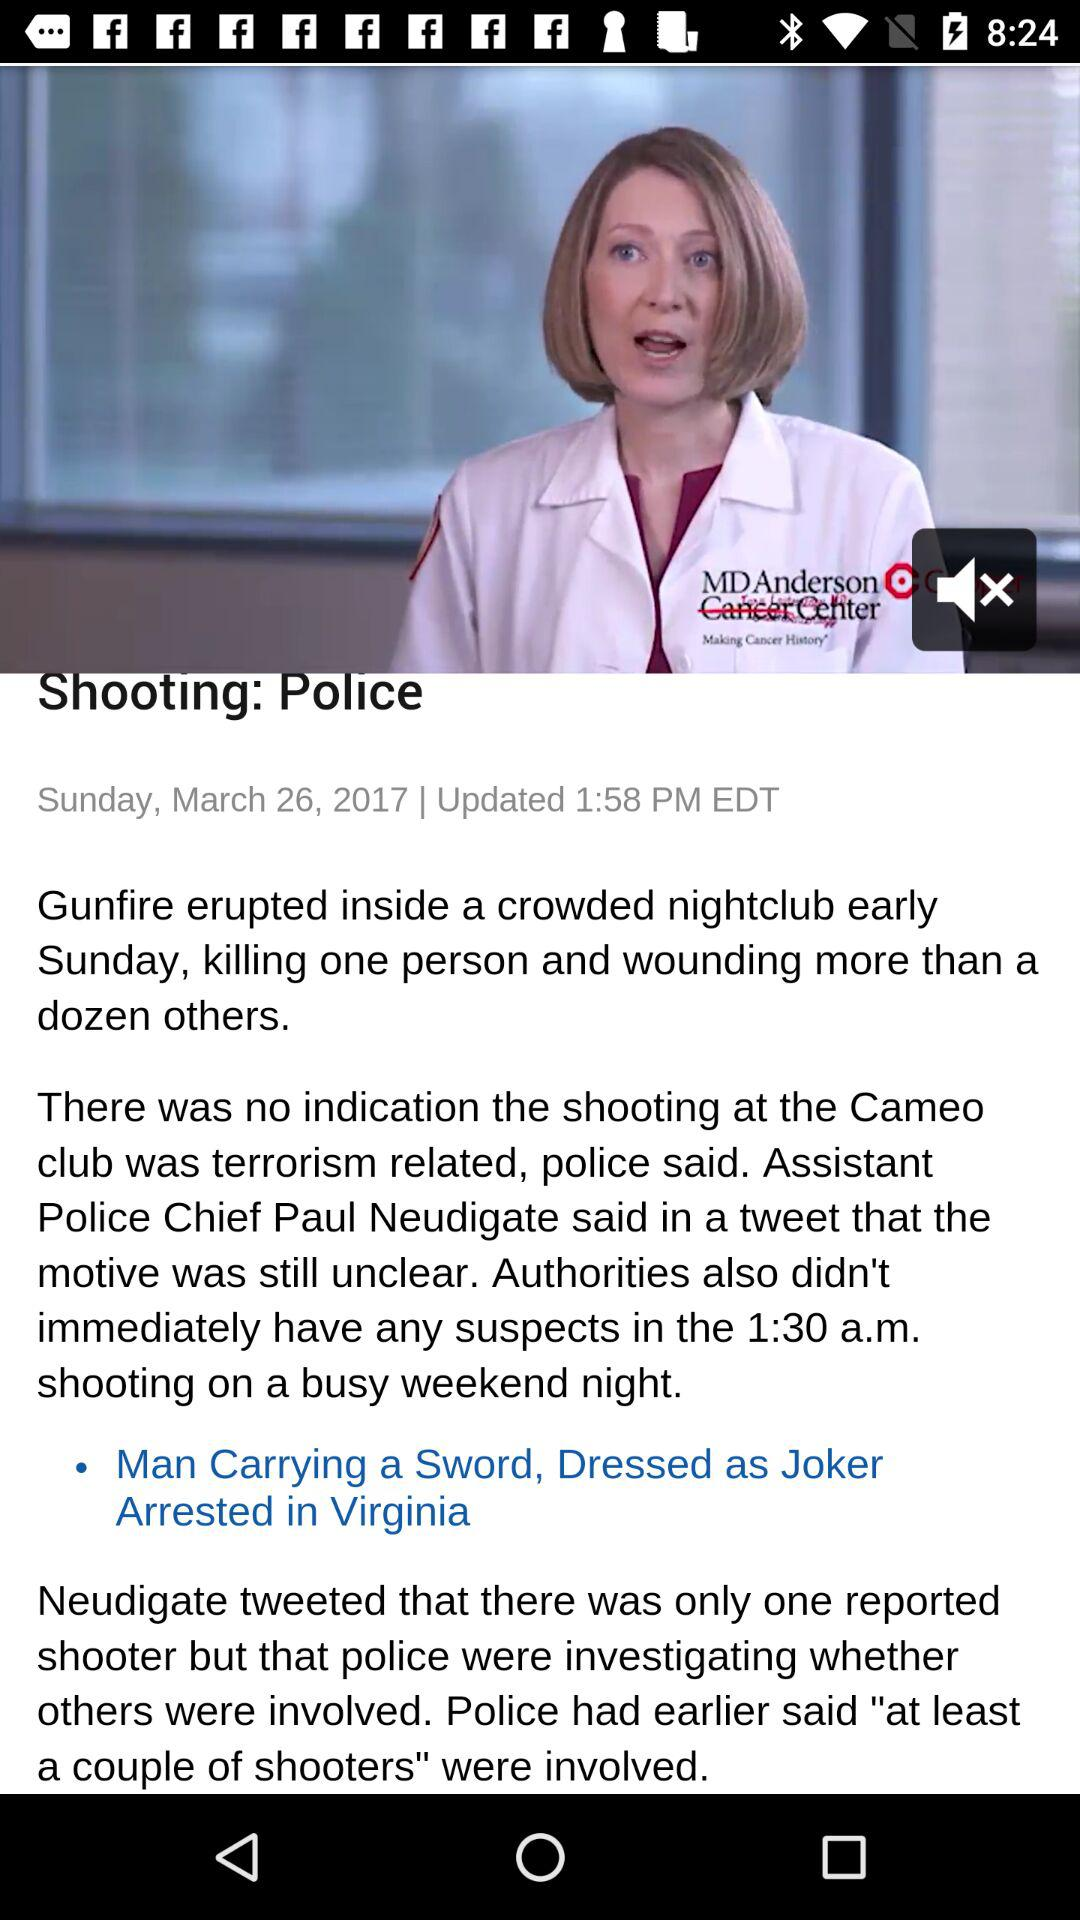What date was the article published? The article was published on Sunday, March 26, 2017. 